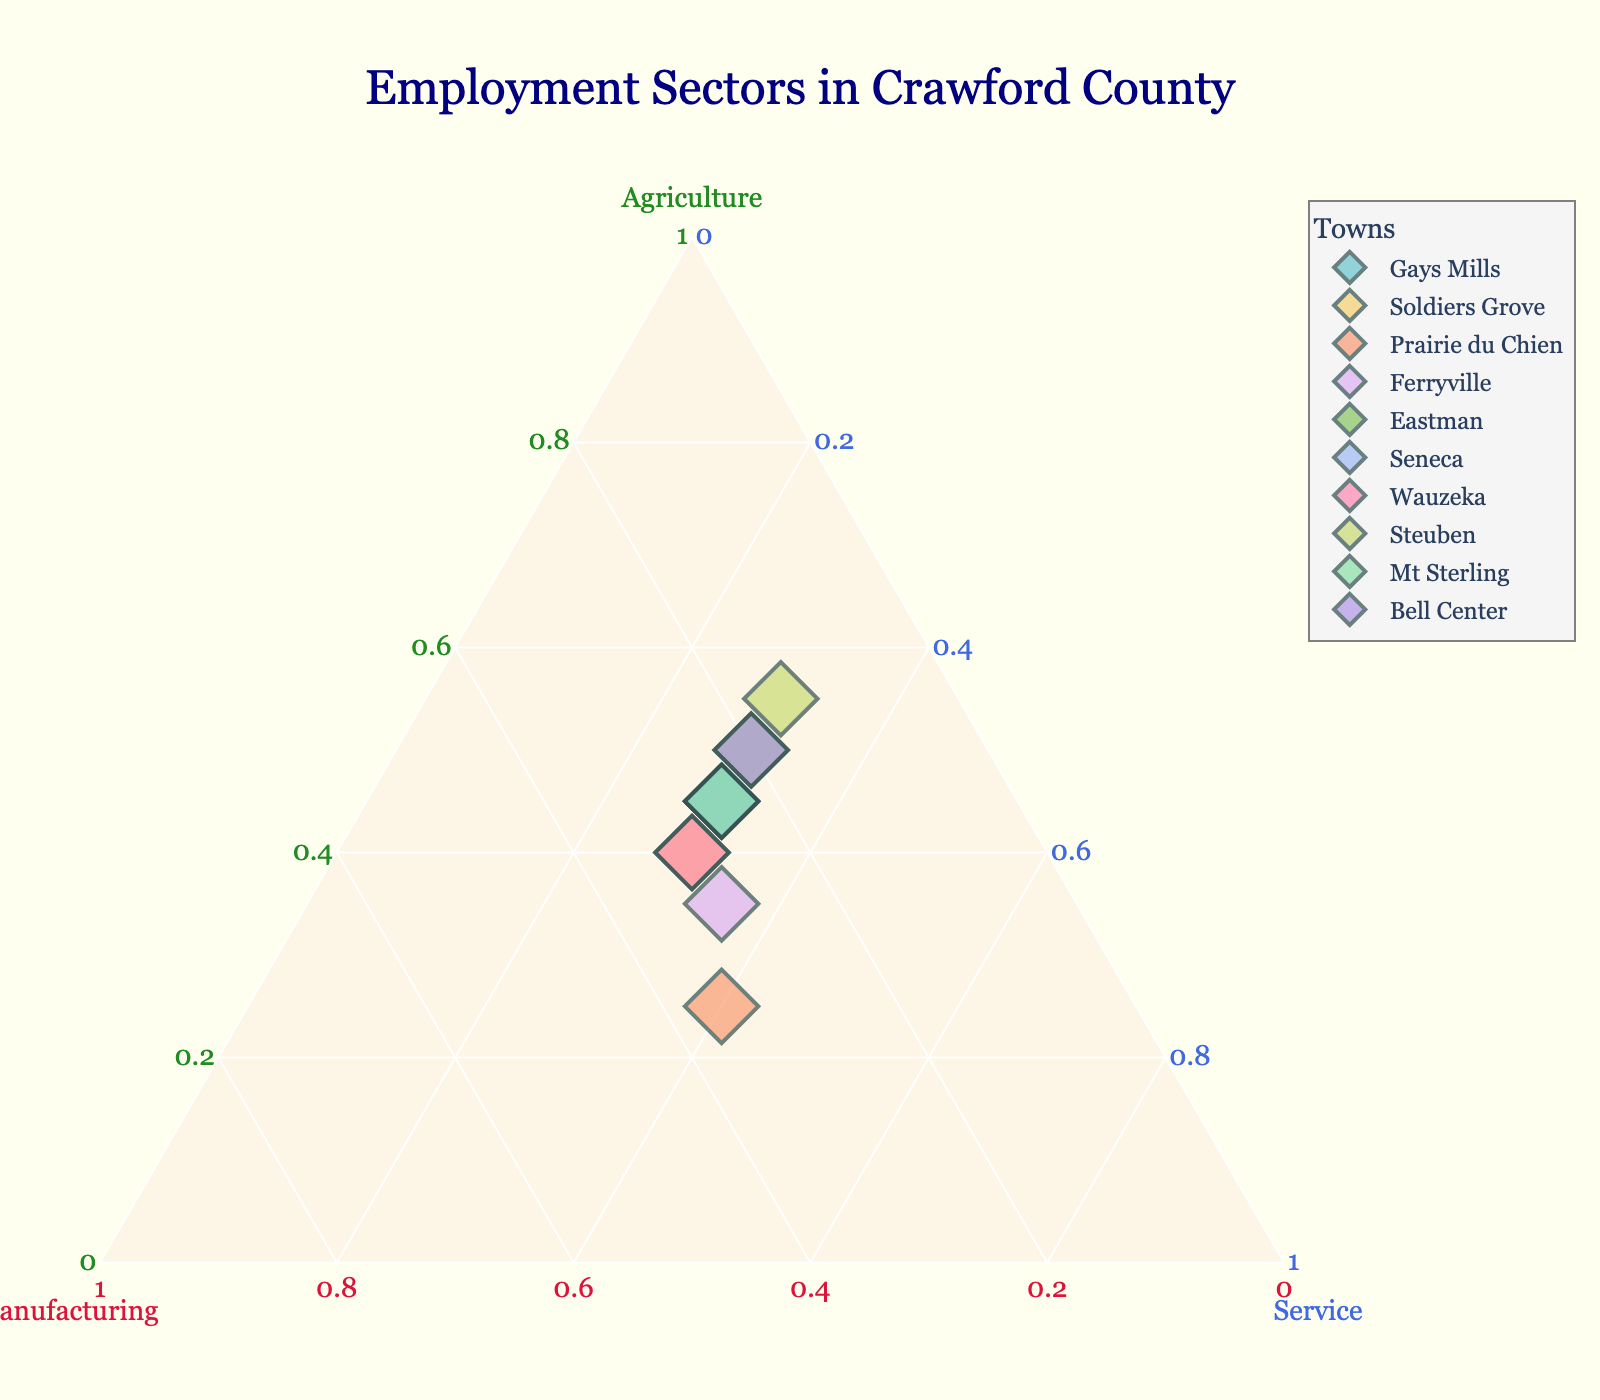what is the title of the figure? The title of the figure is positioned at the top and is highlighted in a larger font size. It states, "Employment Sectors in Crawford County."
Answer: Employment Sectors in Crawford County how many data points are there in the figure? Each town represents a data point, and there are a total of ten towns listed in the data: Gays Mills, Soldiers Grove, Prairie du Chien, Ferryville, Eastman, Seneca, Wauzeka, Steuben, Mt Sterling, and Bell Center.
Answer: 10 which sector does Gays Mills have the most employment in? The ternary plot shows the proportion of agriculture, manufacturing, and service sectors. For Gays Mills, it reaches the highest value at the 'Agriculture' corner.
Answer: Agriculture which town has the highest percentage of manufacturing employment? By checking the position of the data points, Prairie du Chien is closest to the manufacturing axis, indicating that it has the highest percentage of manufacturing employment at 35%.
Answer: Prairie du Chien what is the employment distribution for Seneca? By locating and hovering over the data point for Seneca, the proportion of employment sectors can be observed. For Seneca, the employment sectors are: Agriculture (45%), Manufacturing (25%), and Service (30%).
Answer: Agriculture: 45%, Manufacturing: 25%, Service: 30% in which town are the agriculture and service sectors equally distributed? Among the towns on the ternary plot, it is noticed that Bell Center is positioned such that agriculture and service both have similar values around 30%, although not perfectly equal.
Answer: Ferryville which towns have a similar employment distribution in the agriculture sector? By reviewing the data points close to each other on the ternary plot, Gays Mills, Seneca, and Mt Sterling all have around 45% employment in the agriculture sector.
Answer: Gays Mills, Seneca, Mt Sterling how is Eastman different from Bell Center in terms of sector distribution? Comparing the positions of Eastman and Bell Center on the ternary plot shows that Eastman has a higher percentage in agriculture and a lower percentage in manufacturing, while Bell Center has an equal percentage in agriculture and service, with lower employment in manufacturing.
Answer: Eastman has more Agriculture and less Manufacturing compared to Bell Center which town has the lowest manufacturing employment, and what are its percentages in agriculture and service sectors? Steuben sits closest to the agriculture and service axis, indicating the lowest manufacturing employment at 15%. The employment distributions for Steuben are: Agriculture (55%), Service (30%).
Answer: Steuben: Agriculture 55%, Service 30%, Manufacturing 15% which town is the most balanced in terms of employment distribution across all sectors? Prairie du Chien is positioned closer to the center of the ternary plot, indicating that it has a relatively balanced distribution with Agriculture (25%), Manufacturing (35%), and Service (40%).
Answer: Prairie du Chien 